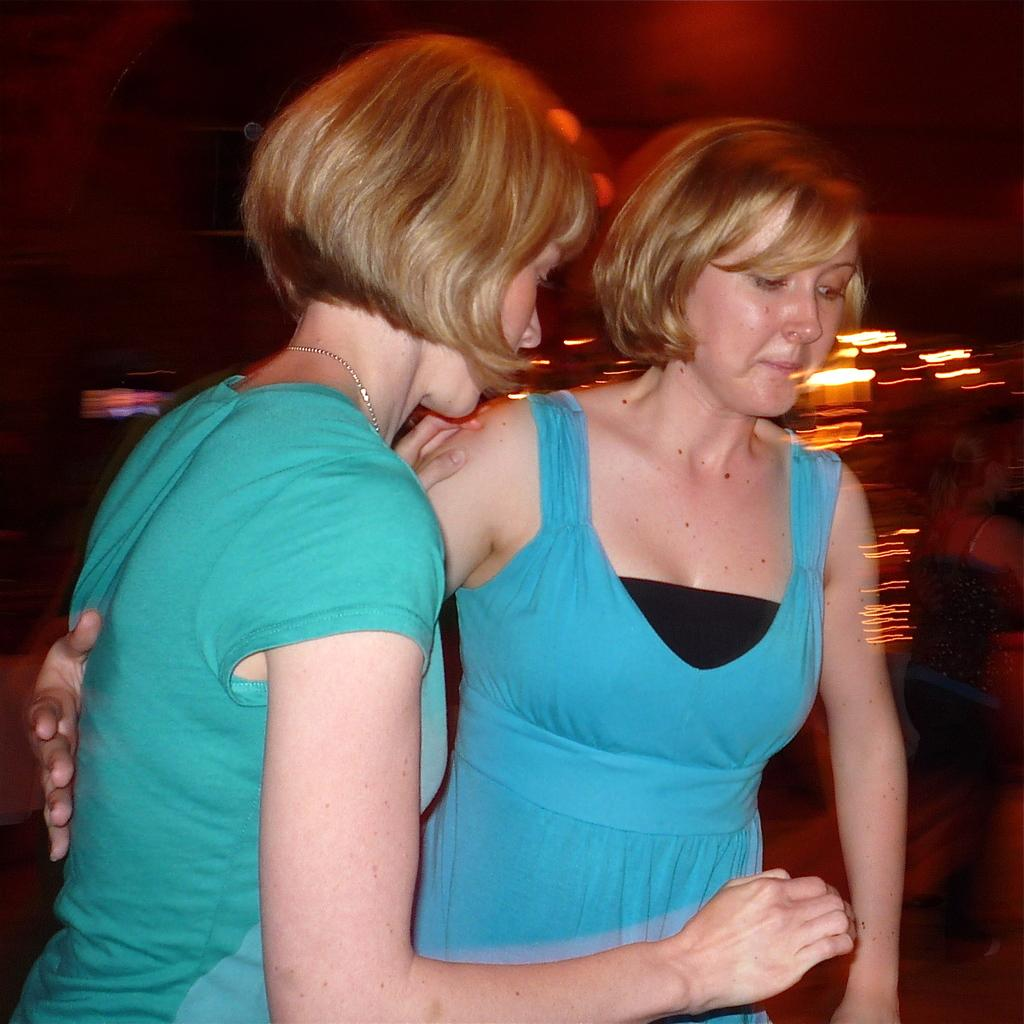How many people are in the front of the image? There are two women in the front of the image. What can be observed about the background of the image? The background of the image is blurry. What type of produce is being used in the chess game in the image? There is no produce or chess game present in the image. 